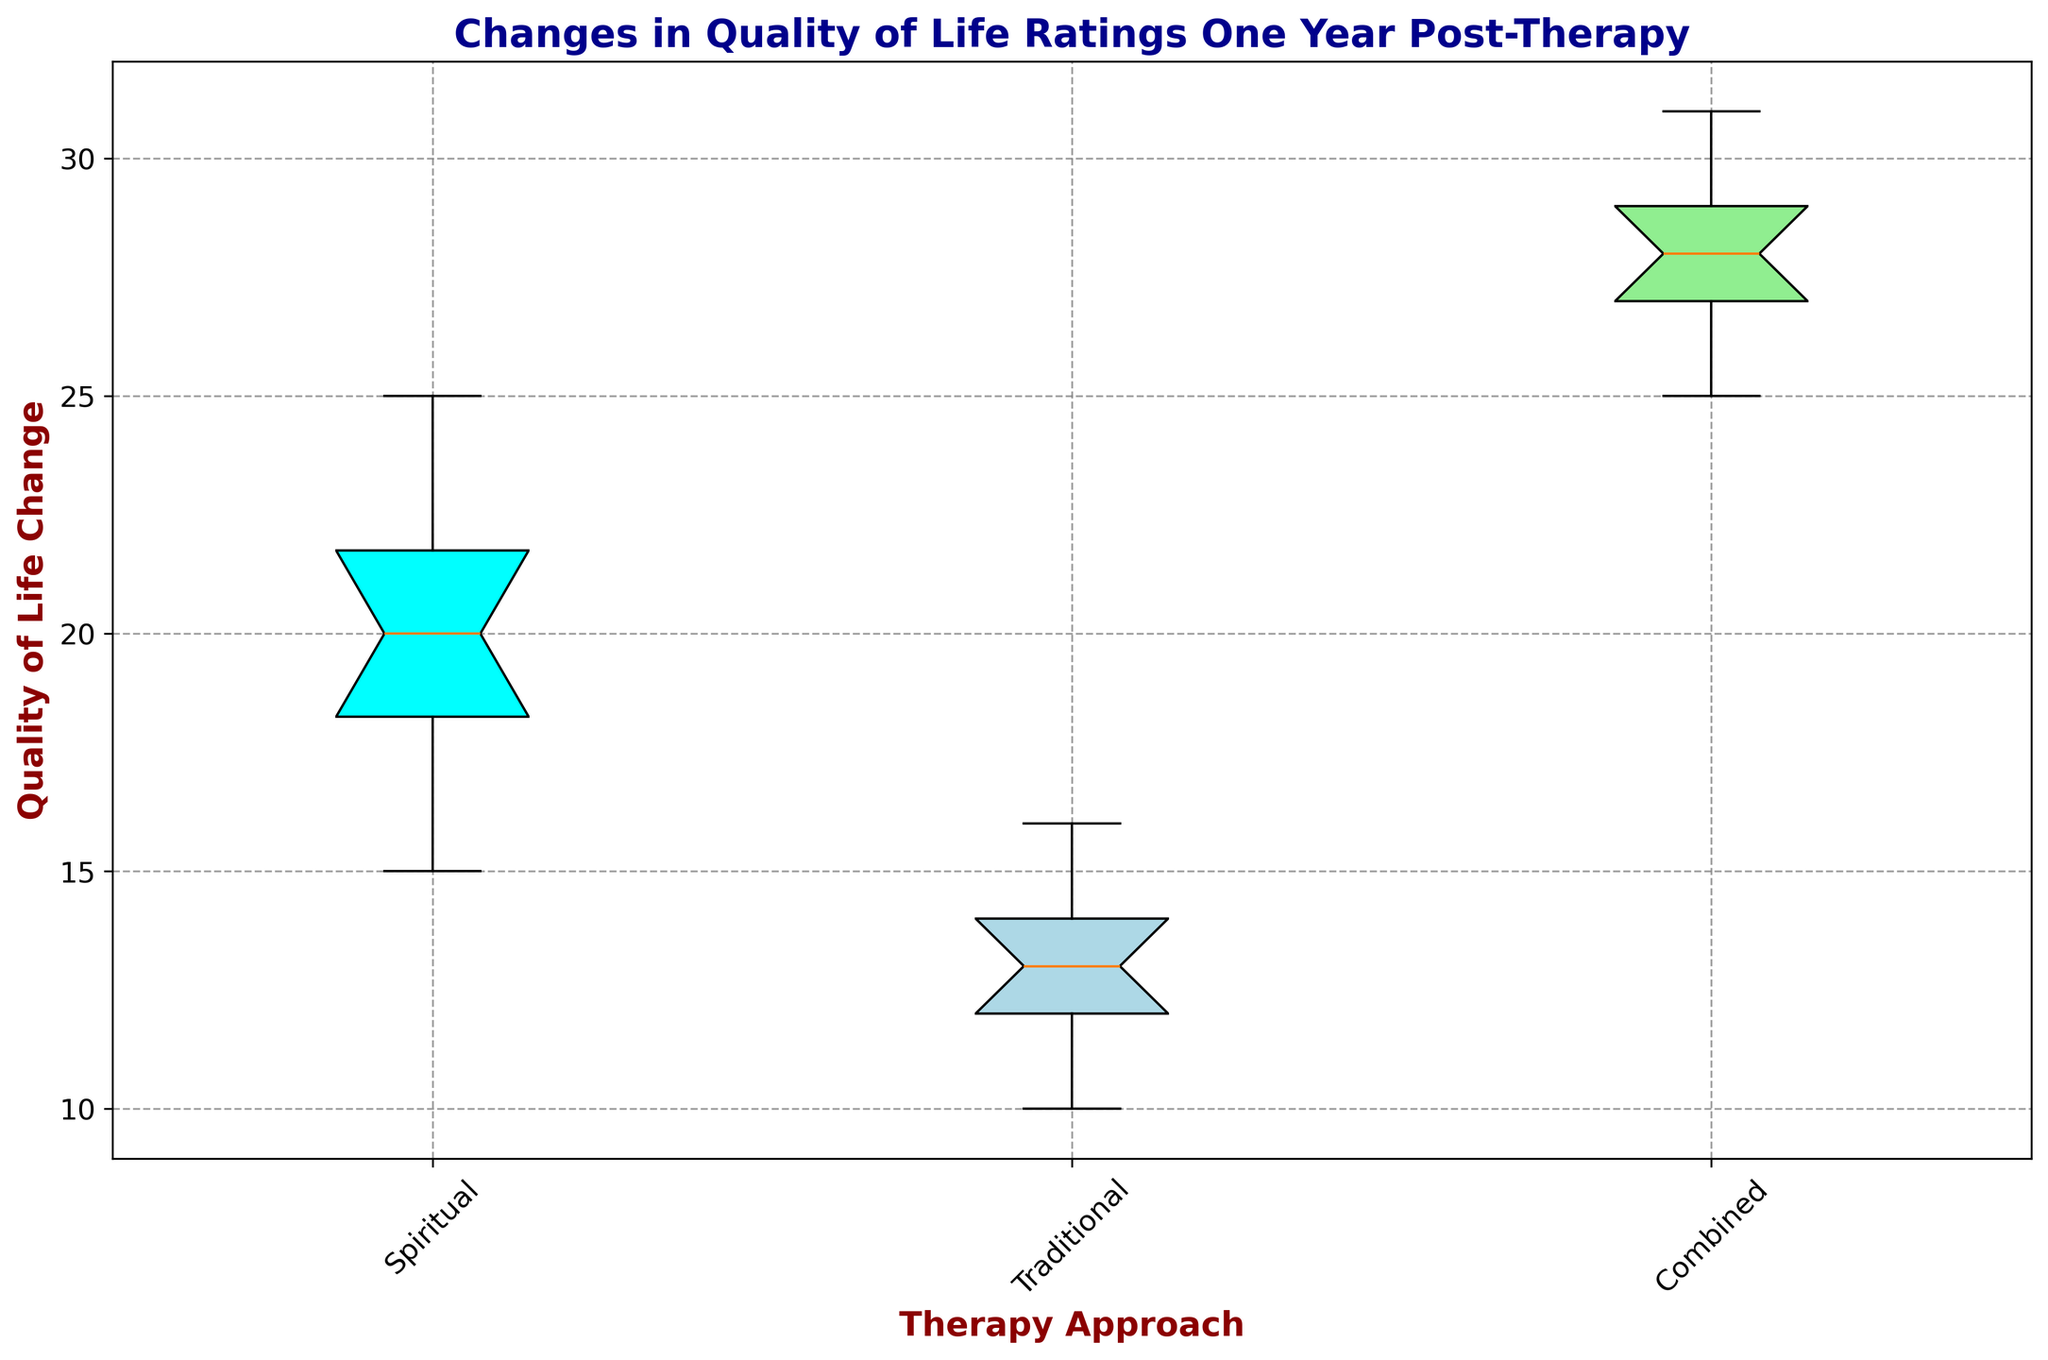Which therapy approach has the highest median quality of life change? Looking at the box plot, the median is denoted by the line inside each box. The highest median value among the approaches is in the "Combined" therapy group.
Answer: Combined What is the difference in the median quality of life change between Spiritual and Traditional therapy? Identify the median values for both groups on the box plot. The median for Spiritual therapy appears higher than that for Traditional therapy. Subtract the Traditional median from the Spiritual median.
Answer: 7 Which therapy approach shows the greatest range in quality of life change? The range is indicated by the length between the smallest and largest data points (whiskers) in each group. The "Combined" therapy group has the largest range visually.
Answer: Combined Visually, how does the interquartile range (IQR) of the Combined therapy approach compare to that of the Traditional approach? The IQR is represented by the length of the box, which signifies the spread between the first and third quartiles. The Combined therapy group has a significantly wider box compared to the Traditional therapy group.
Answer: Wider What is the minimum quality of life change for the Traditional therapy approach? The minimum value is indicated by the bottom whisker of the box plot in the Traditional group.
Answer: 10 What are the upper and lower quartiles for the Spiritual therapy approach? The upper quartile (Q3) and lower quartile (Q1) are represented by the top and bottom edges of the box. For Spiritual, visually estimate these values.
Answer: 22 (Q3), 18 (Q1) How does the variability in quality of life changes in the Traditional therapy group compare to the Combined therapy group? Variability is suggested by the spread of the box and whiskers. Traditional therapy has a narrower box and shorter whiskers, indicating less variability compared to the Combined therapy group.
Answer: Less variability If you were to combine the medians of all three groups, what would the total be? Identify and sum up the median values of the Spiritual, Traditional, and Combined groups.
Answer: 59 Which therapy approach has the smallest interquartile range (IQR)? The smallest IQR is indicated by the shortest box in the box plot. The Traditional therapy group has the smallest IQR.
Answer: Traditional Compare the highest quality of life changes among the three therapy approaches. Which shows the highest value and what is it? The highest value is indicated by the top whisker (or any outliers above the box) for each group. The highest value appears in the Combined therapy group.
Answer: 31 